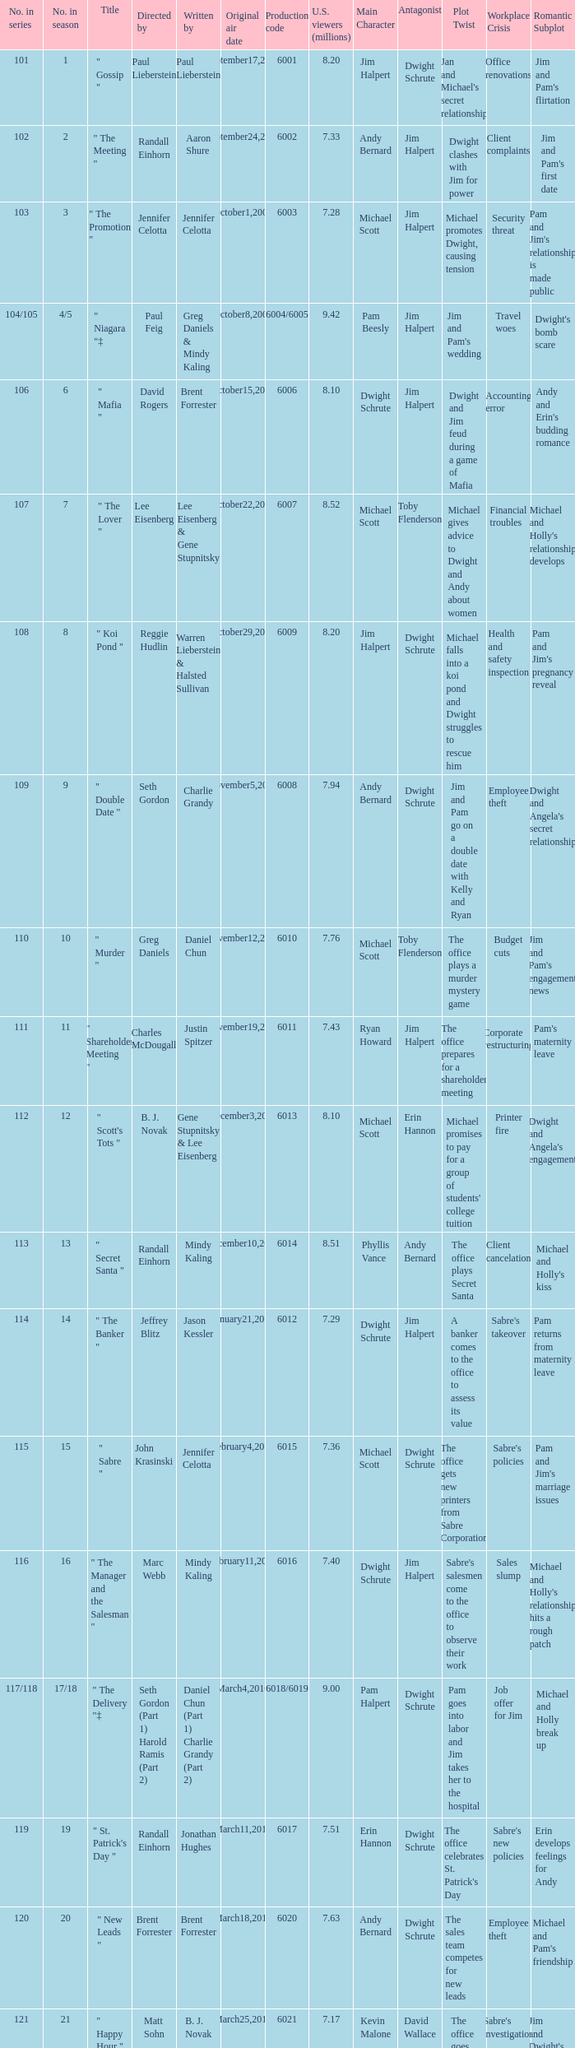Name the production code for number in season being 21 6021.0. 